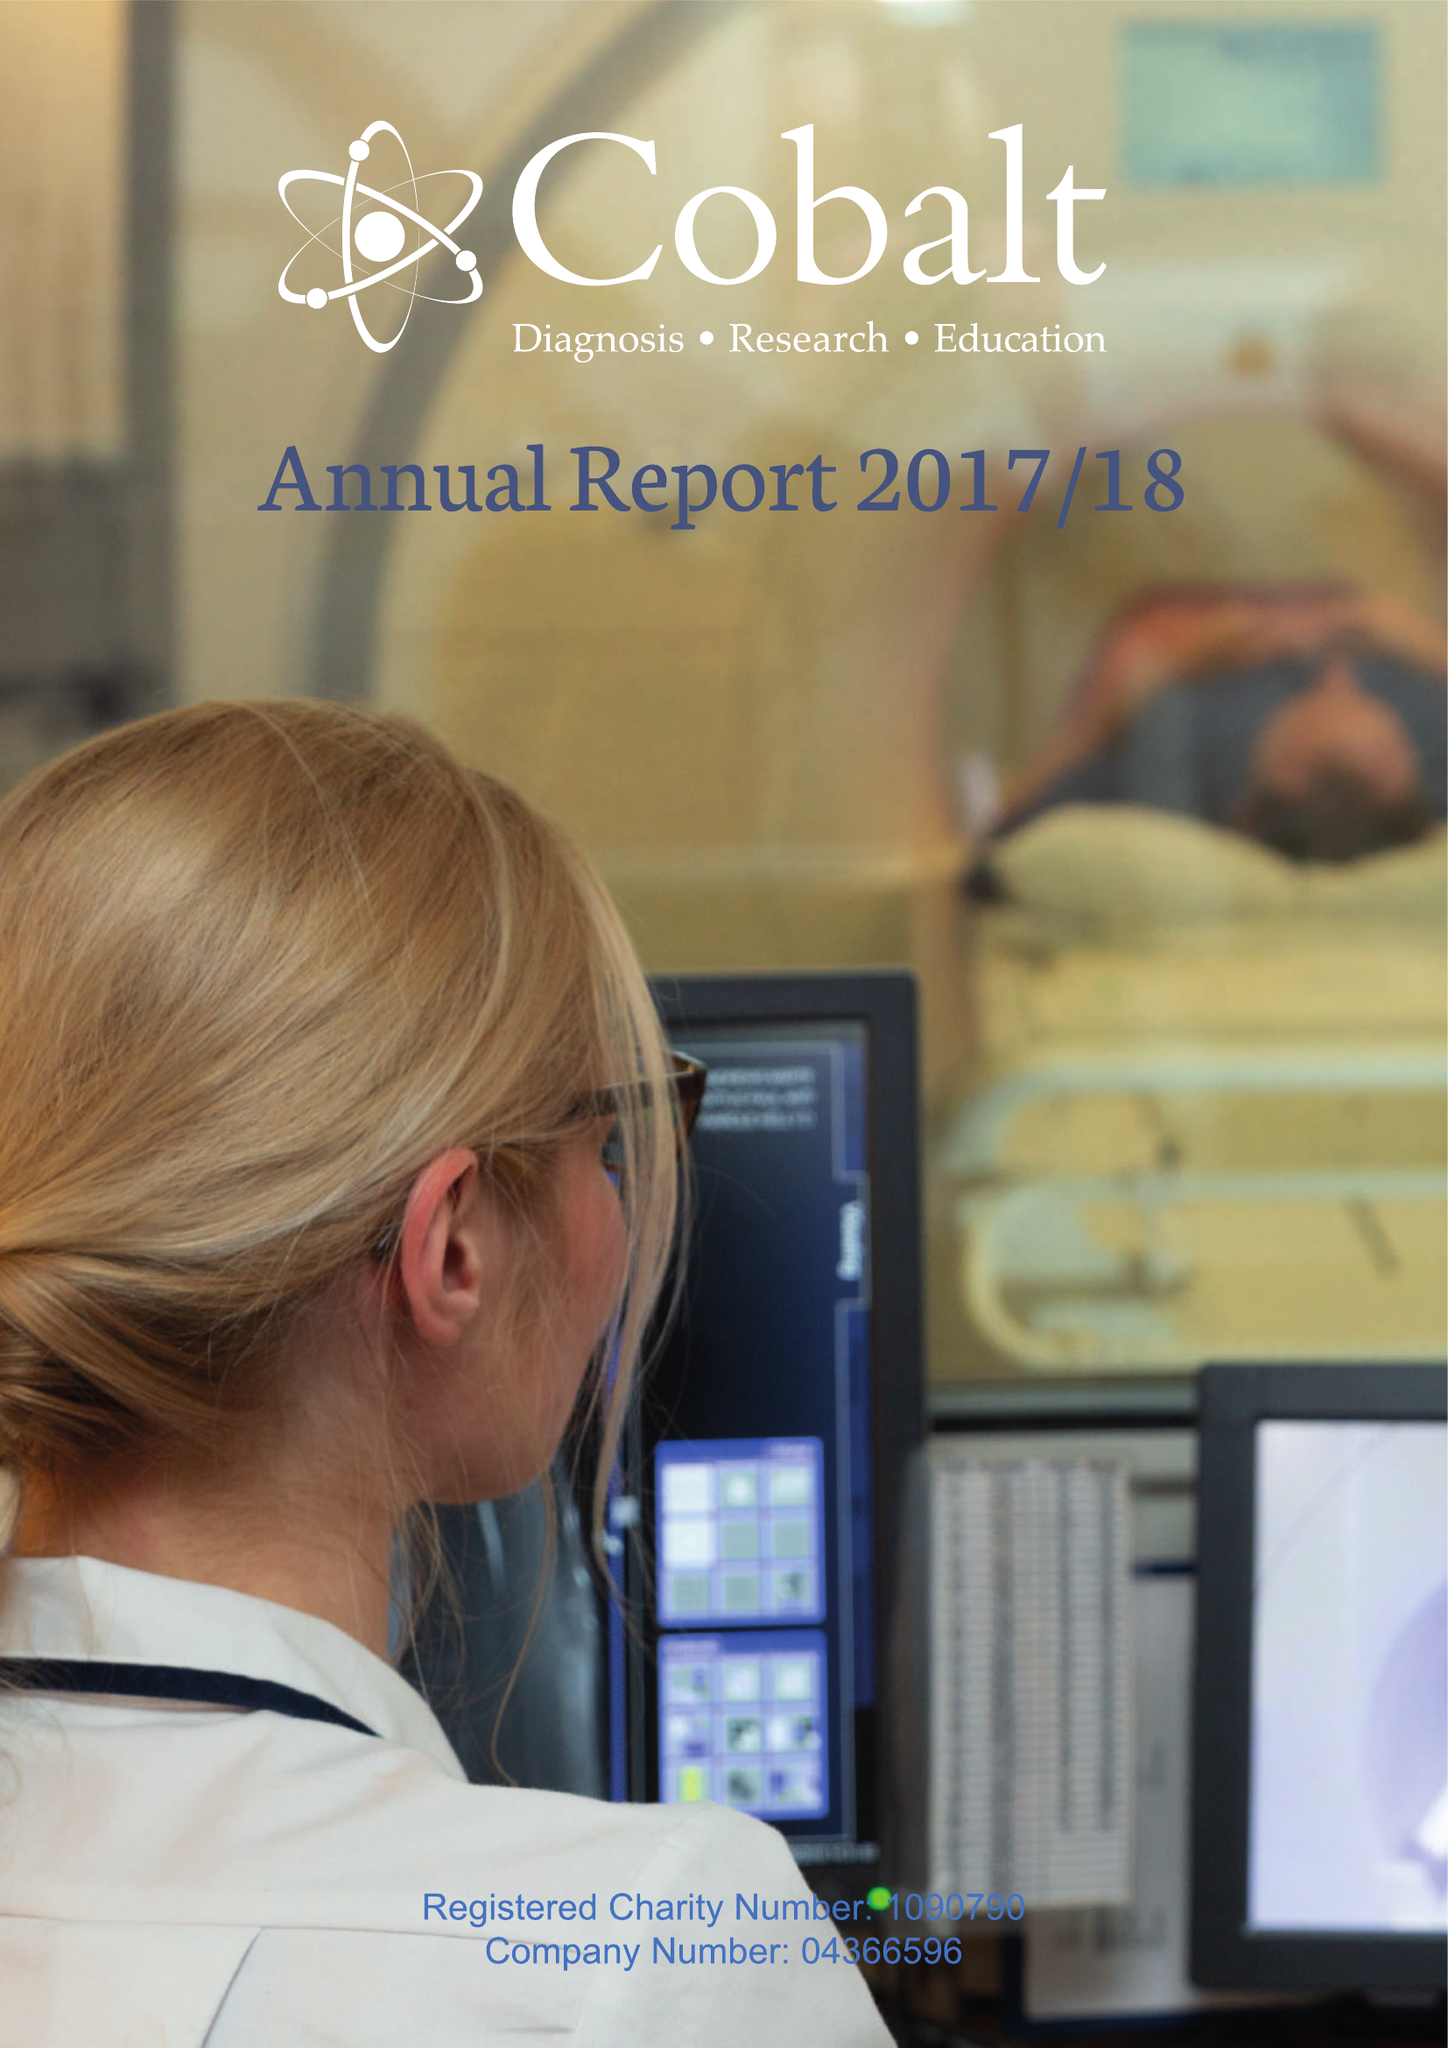What is the value for the address__post_town?
Answer the question using a single word or phrase. CHELTENHAM 